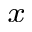<formula> <loc_0><loc_0><loc_500><loc_500>_ { x }</formula> 